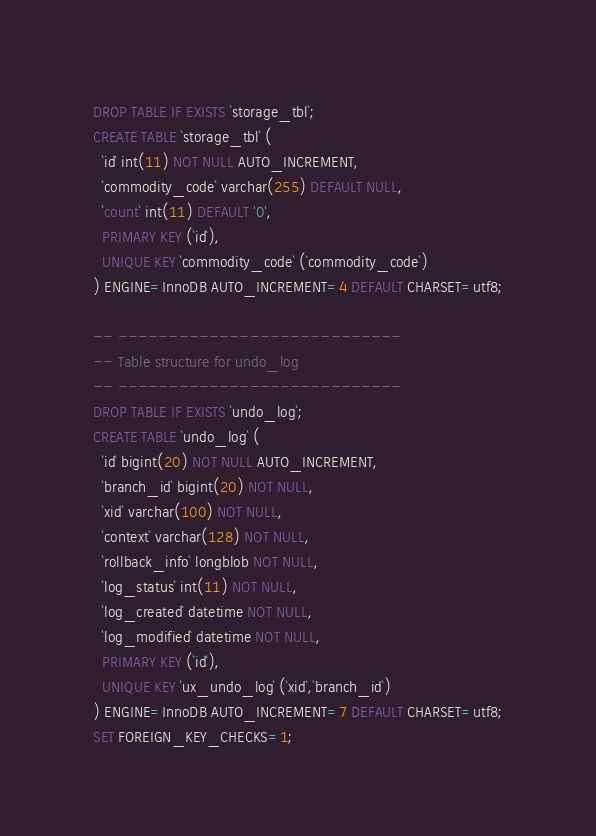Convert code to text. <code><loc_0><loc_0><loc_500><loc_500><_SQL_>DROP TABLE IF EXISTS `storage_tbl`;
CREATE TABLE `storage_tbl` (
  `id` int(11) NOT NULL AUTO_INCREMENT,
  `commodity_code` varchar(255) DEFAULT NULL,
  `count` int(11) DEFAULT '0',
  PRIMARY KEY (`id`),
  UNIQUE KEY `commodity_code` (`commodity_code`)
) ENGINE=InnoDB AUTO_INCREMENT=4 DEFAULT CHARSET=utf8;

-- ----------------------------
-- Table structure for undo_log
-- ----------------------------
DROP TABLE IF EXISTS `undo_log`;
CREATE TABLE `undo_log` (
  `id` bigint(20) NOT NULL AUTO_INCREMENT,
  `branch_id` bigint(20) NOT NULL,
  `xid` varchar(100) NOT NULL,
  `context` varchar(128) NOT NULL,
  `rollback_info` longblob NOT NULL,
  `log_status` int(11) NOT NULL,
  `log_created` datetime NOT NULL,
  `log_modified` datetime NOT NULL,
  PRIMARY KEY (`id`),
  UNIQUE KEY `ux_undo_log` (`xid`,`branch_id`)
) ENGINE=InnoDB AUTO_INCREMENT=7 DEFAULT CHARSET=utf8;
SET FOREIGN_KEY_CHECKS=1;
</code> 